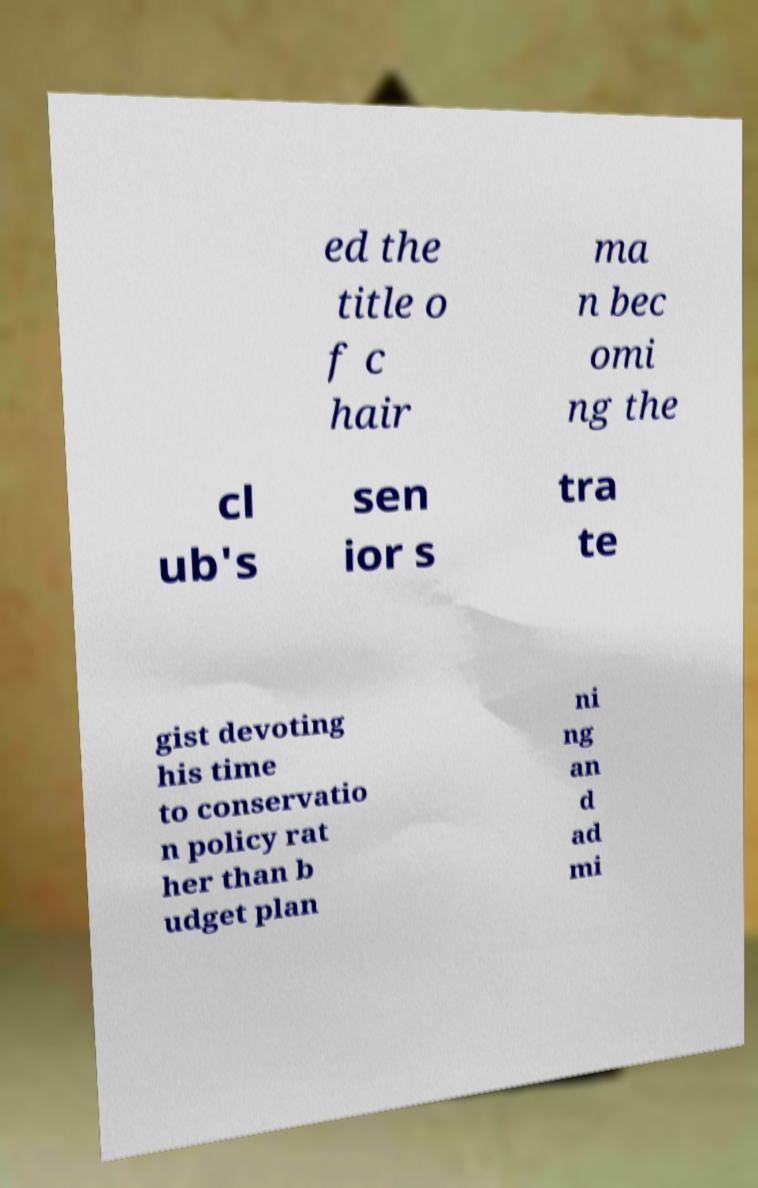Can you read and provide the text displayed in the image?This photo seems to have some interesting text. Can you extract and type it out for me? ed the title o f c hair ma n bec omi ng the cl ub's sen ior s tra te gist devoting his time to conservatio n policy rat her than b udget plan ni ng an d ad mi 